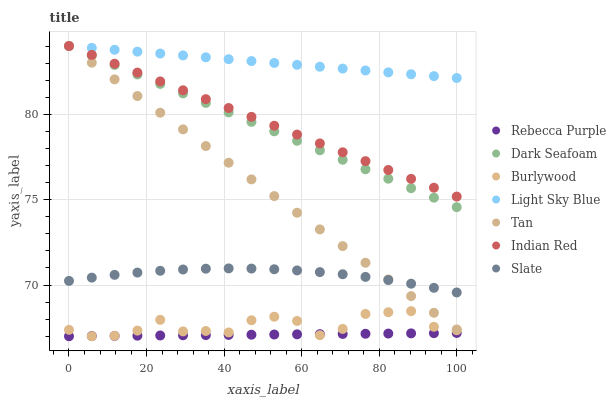Does Rebecca Purple have the minimum area under the curve?
Answer yes or no. Yes. Does Light Sky Blue have the maximum area under the curve?
Answer yes or no. Yes. Does Slate have the minimum area under the curve?
Answer yes or no. No. Does Slate have the maximum area under the curve?
Answer yes or no. No. Is Tan the smoothest?
Answer yes or no. Yes. Is Burlywood the roughest?
Answer yes or no. Yes. Is Slate the smoothest?
Answer yes or no. No. Is Slate the roughest?
Answer yes or no. No. Does Burlywood have the lowest value?
Answer yes or no. Yes. Does Slate have the lowest value?
Answer yes or no. No. Does Tan have the highest value?
Answer yes or no. Yes. Does Slate have the highest value?
Answer yes or no. No. Is Rebecca Purple less than Light Sky Blue?
Answer yes or no. Yes. Is Indian Red greater than Burlywood?
Answer yes or no. Yes. Does Light Sky Blue intersect Dark Seafoam?
Answer yes or no. Yes. Is Light Sky Blue less than Dark Seafoam?
Answer yes or no. No. Is Light Sky Blue greater than Dark Seafoam?
Answer yes or no. No. Does Rebecca Purple intersect Light Sky Blue?
Answer yes or no. No. 